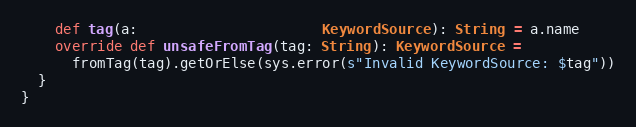Convert code to text. <code><loc_0><loc_0><loc_500><loc_500><_Scala_>    def tag(a:                      KeywordSource): String = a.name
    override def unsafeFromTag(tag: String): KeywordSource =
      fromTag(tag).getOrElse(sys.error(s"Invalid KeywordSource: $tag"))
  }
}
</code> 